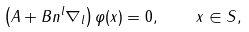Convert formula to latex. <formula><loc_0><loc_0><loc_500><loc_500>\left ( A + B n ^ { l } \nabla _ { l } \right ) \varphi ( x ) = 0 , \quad x \in S ,</formula> 